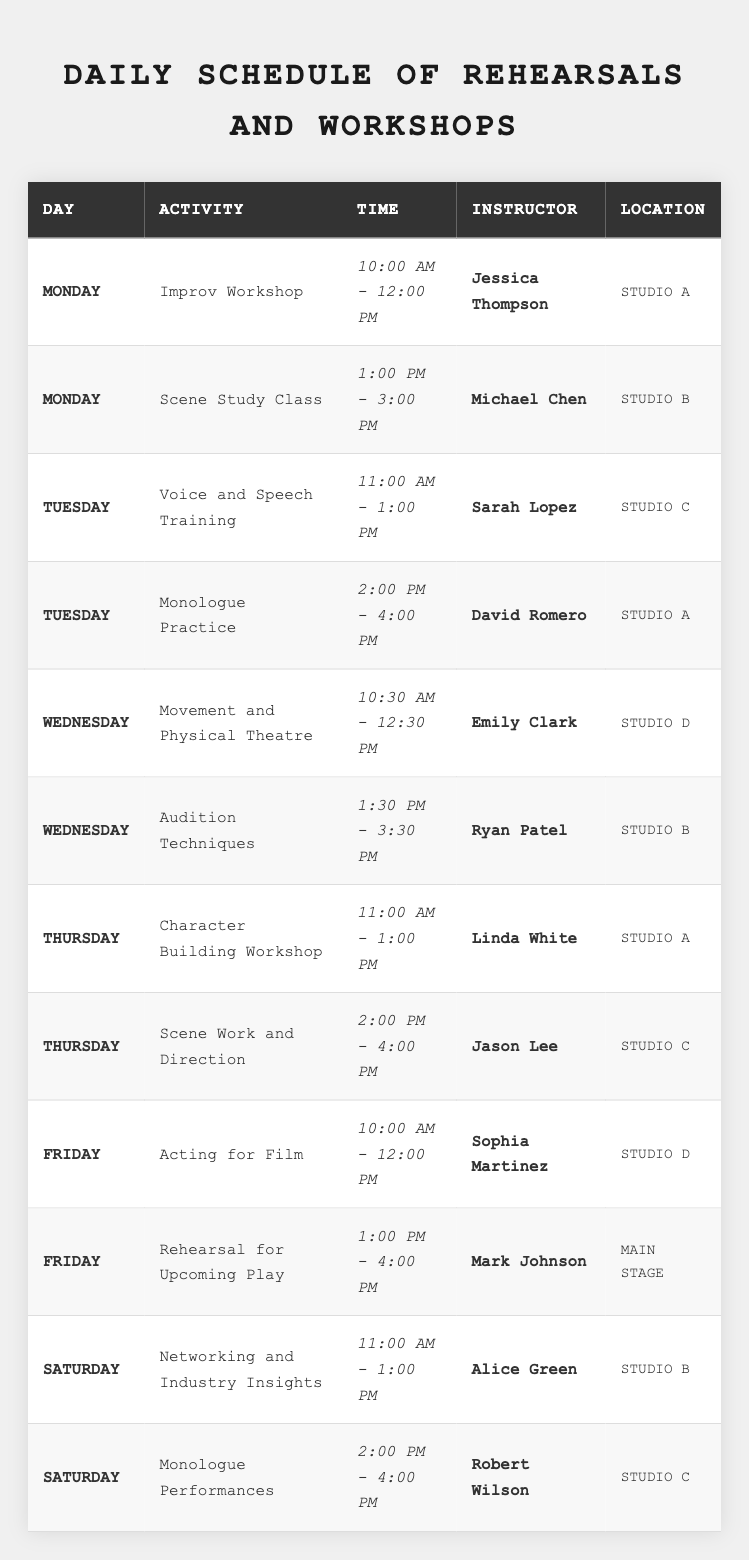What is the first activity scheduled on Monday? The first activity listed for Monday is the "Improv Workshop," starting at 10:00 AM.
Answer: Improv Workshop Who teaches the "Scene Work and Direction" workshop? The table shows that the "Scene Work and Direction" workshop is taught by Jason Lee.
Answer: Jason Lee How many activities are scheduled on Tuesday? There are two activities on Tuesday: "Voice and Speech Training" and "Monologue Practice."
Answer: 2 Is there a class on Friday that focuses on film? The table indicates that there is a class called "Acting for Film" on Friday.
Answer: Yes What are the activities planned for Wednesday? The activities on Wednesday are "Movement and Physical Theatre" from 10:30 AM - 12:30 PM and "Audition Techniques" from 1:30 PM - 3:30 PM.
Answer: 2 Which instructor has a class in Studio C? The "Voice and Speech Training" class taught by Sarah Lopez and "Scene Work and Direction" taught by Jason Lee are held in Studio C.
Answer: Sarah Lopez, Jason Lee What is the total duration of the "Rehearsal for Upcoming Play"? The "Rehearsal for Upcoming Play" is scheduled from 1:00 PM to 4:00 PM, which is a duration of 3 hours.
Answer: 3 hours On which day is "Networking and Industry Insights" held? According to the table, the "Networking and Industry Insights" session is on Saturday.
Answer: Saturday Which activity occurs just before "Monologue Performances" on Saturday? "Networking and Industry Insights" takes place just before "Monologue Performances" on Saturday.
Answer: Networking and Industry Insights How many different locations are used across the week? The table shows three unique locations: Studio A, Studio B, and Studio C, with Main Stage included as well.
Answer: 4 locations What is the average starting time of activities on Thursday? The classes on Thursday start at 11:00 AM and 2:00 PM. Converting these to a 24-hour format (11:00 and 14:00), their average time is (11:00 + 14:00)/2 = 12:30.
Answer: 12:30 PM Which day has the most workshops and classes? By reviewing the table, Friday has two scheduled activities, which is the highest number compared to other days.
Answer: Friday Are there any classes that start at the same time on different days? Yes, both "Improv Workshop" on Monday and "Acting for Film" on Friday start at 10:00 AM.
Answer: Yes 